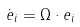Convert formula to latex. <formula><loc_0><loc_0><loc_500><loc_500>\dot { e } _ { i } = \Omega \cdot e _ { i }</formula> 